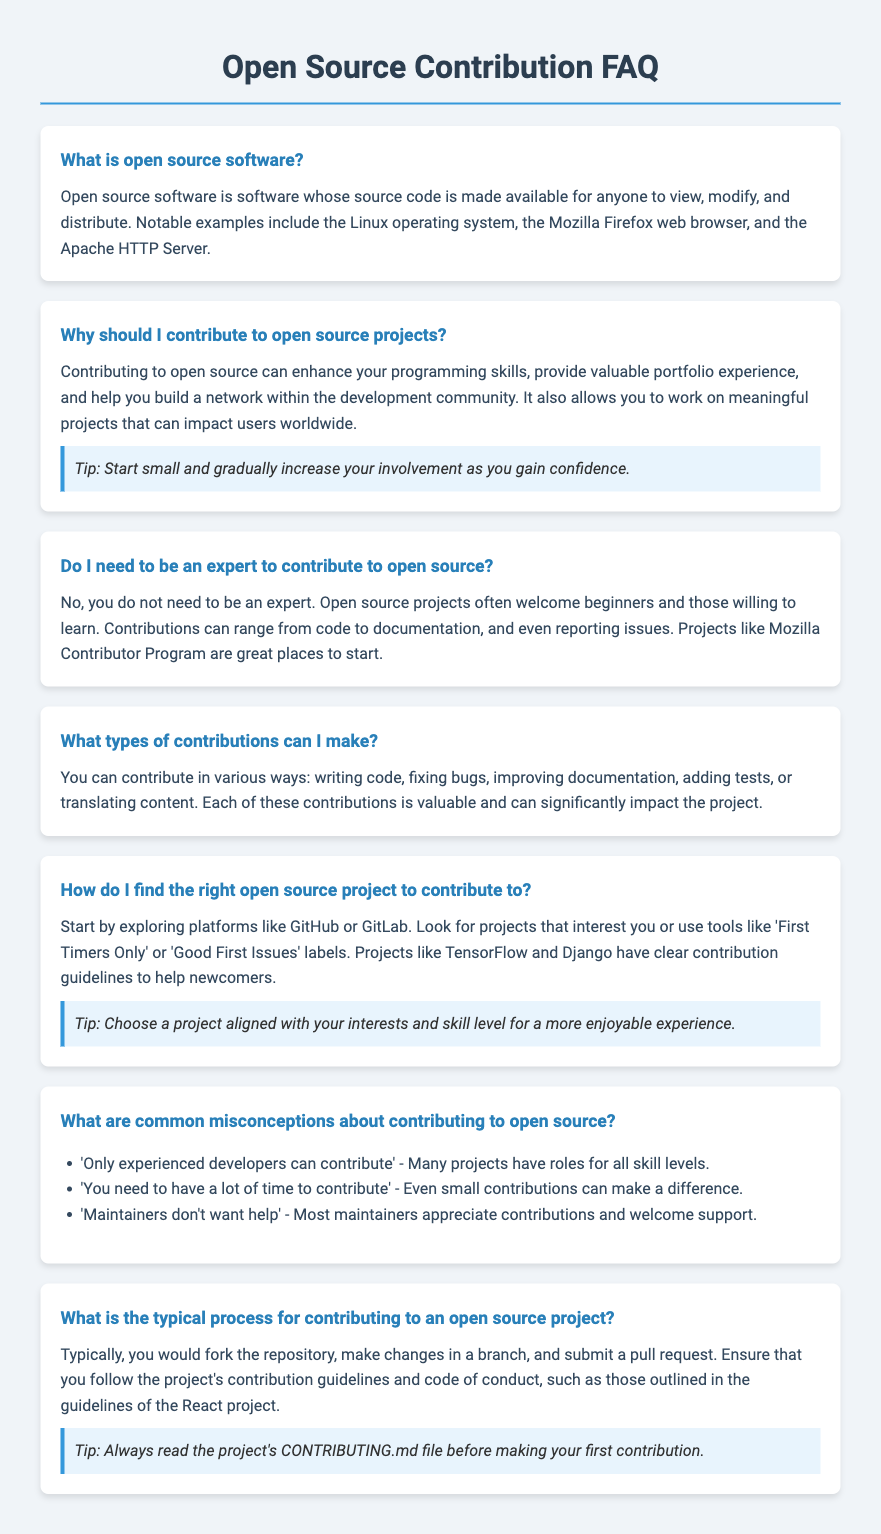What is open source software? The document states that open source software is software whose source code is made available for anyone to view, modify, and distribute.
Answer: Software whose source code is made available Why should I contribute to open source projects? The document explains that contributing can enhance skills, provide portfolio experience, build a network, and allow work on meaningful projects.
Answer: Enhance programming skills What types of contributions can I make? According to the document, contributions can include code writing, bug fixing, documentation improving, test adding, or content translating.
Answer: Writing code What should you do before making your first contribution? The document mentions that you should always read the project's CONTRIBUTING.md file before making your first contribution.
Answer: Read the CONTRIBUTING.md file What are common misconceptions about contributing to open source? The document lists several misconceptions, such as "Only experienced developers can contribute" and "Maintainers don't want help."
Answer: Only experienced developers can contribute How do I find the right open source project? The document suggests exploring platforms like GitHub or GitLab and looking for projects of interest with certain labels.
Answer: GitHub or GitLab 